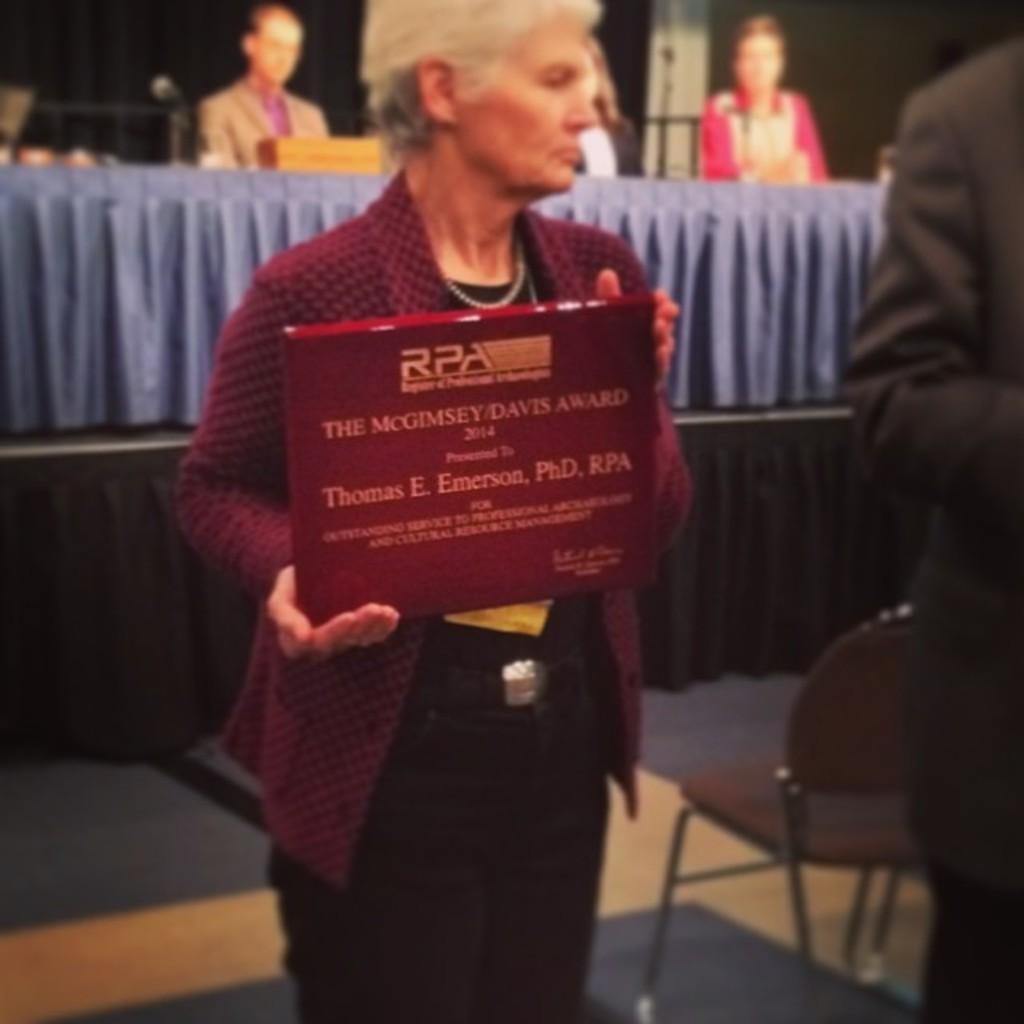Please provide a concise description of this image. In the picture I can see a person wearing maroon color jacket is holding an object in her hands. The surrounding of the image is blurred, here I can see a chair and a person standing on the right side of the image. In the background, I can see a few people are sitting near the table. 